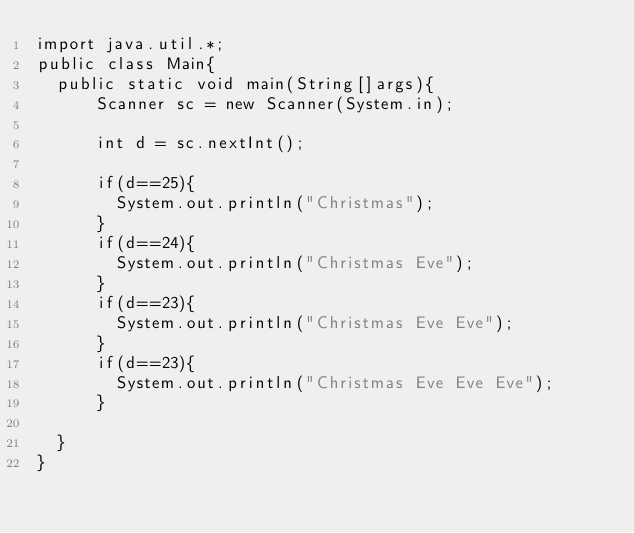<code> <loc_0><loc_0><loc_500><loc_500><_Java_>import java.util.*;
public class Main{
  public static void main(String[]args){
      Scanner sc = new Scanner(System.in);

      int d = sc.nextInt();

      if(d==25){
        System.out.println("Christmas");
      }
      if(d==24){
        System.out.println("Christmas Eve");
      }
      if(d==23){
        System.out.println("Christmas Eve Eve");
      }
      if(d==23){
        System.out.println("Christmas Eve Eve Eve");
      }
      
  }
}</code> 